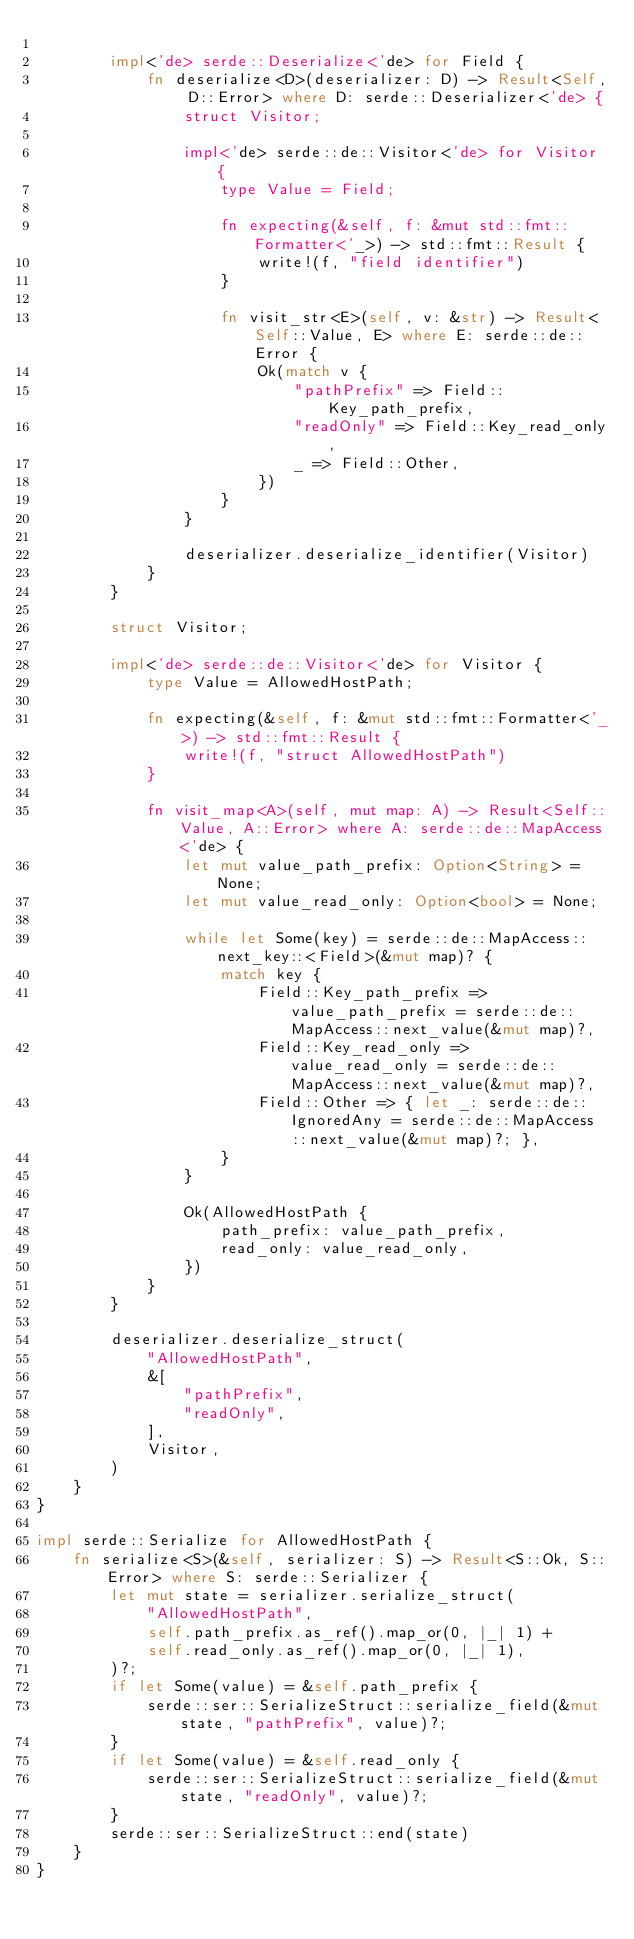Convert code to text. <code><loc_0><loc_0><loc_500><loc_500><_Rust_>
        impl<'de> serde::Deserialize<'de> for Field {
            fn deserialize<D>(deserializer: D) -> Result<Self, D::Error> where D: serde::Deserializer<'de> {
                struct Visitor;

                impl<'de> serde::de::Visitor<'de> for Visitor {
                    type Value = Field;

                    fn expecting(&self, f: &mut std::fmt::Formatter<'_>) -> std::fmt::Result {
                        write!(f, "field identifier")
                    }

                    fn visit_str<E>(self, v: &str) -> Result<Self::Value, E> where E: serde::de::Error {
                        Ok(match v {
                            "pathPrefix" => Field::Key_path_prefix,
                            "readOnly" => Field::Key_read_only,
                            _ => Field::Other,
                        })
                    }
                }

                deserializer.deserialize_identifier(Visitor)
            }
        }

        struct Visitor;

        impl<'de> serde::de::Visitor<'de> for Visitor {
            type Value = AllowedHostPath;

            fn expecting(&self, f: &mut std::fmt::Formatter<'_>) -> std::fmt::Result {
                write!(f, "struct AllowedHostPath")
            }

            fn visit_map<A>(self, mut map: A) -> Result<Self::Value, A::Error> where A: serde::de::MapAccess<'de> {
                let mut value_path_prefix: Option<String> = None;
                let mut value_read_only: Option<bool> = None;

                while let Some(key) = serde::de::MapAccess::next_key::<Field>(&mut map)? {
                    match key {
                        Field::Key_path_prefix => value_path_prefix = serde::de::MapAccess::next_value(&mut map)?,
                        Field::Key_read_only => value_read_only = serde::de::MapAccess::next_value(&mut map)?,
                        Field::Other => { let _: serde::de::IgnoredAny = serde::de::MapAccess::next_value(&mut map)?; },
                    }
                }

                Ok(AllowedHostPath {
                    path_prefix: value_path_prefix,
                    read_only: value_read_only,
                })
            }
        }

        deserializer.deserialize_struct(
            "AllowedHostPath",
            &[
                "pathPrefix",
                "readOnly",
            ],
            Visitor,
        )
    }
}

impl serde::Serialize for AllowedHostPath {
    fn serialize<S>(&self, serializer: S) -> Result<S::Ok, S::Error> where S: serde::Serializer {
        let mut state = serializer.serialize_struct(
            "AllowedHostPath",
            self.path_prefix.as_ref().map_or(0, |_| 1) +
            self.read_only.as_ref().map_or(0, |_| 1),
        )?;
        if let Some(value) = &self.path_prefix {
            serde::ser::SerializeStruct::serialize_field(&mut state, "pathPrefix", value)?;
        }
        if let Some(value) = &self.read_only {
            serde::ser::SerializeStruct::serialize_field(&mut state, "readOnly", value)?;
        }
        serde::ser::SerializeStruct::end(state)
    }
}
</code> 